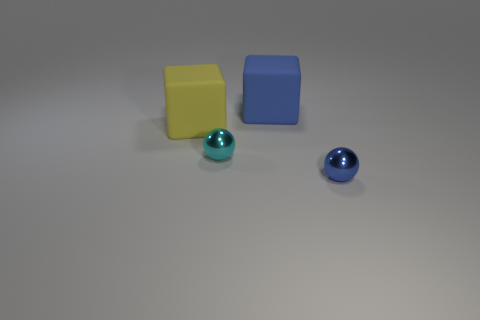Does the large yellow thing have the same material as the tiny cyan ball?
Provide a short and direct response. No. There is another rubber thing that is the same shape as the big blue object; what is its color?
Keep it short and to the point. Yellow. Do the block that is to the left of the cyan metal ball and the blue matte thing have the same size?
Provide a short and direct response. Yes. What number of blue balls are made of the same material as the yellow cube?
Give a very brief answer. 0. What is the material of the block left of the small metal ball that is behind the shiny object that is on the right side of the small cyan shiny ball?
Your answer should be very brief. Rubber. There is a big rubber cube on the right side of the tiny thing that is behind the blue metal ball; what color is it?
Give a very brief answer. Blue. The thing that is the same size as the blue shiny sphere is what color?
Keep it short and to the point. Cyan. How many large objects are cyan metal objects or balls?
Your answer should be compact. 0. Is the number of big rubber blocks that are behind the yellow rubber thing greater than the number of cyan shiny things in front of the small cyan metallic thing?
Offer a very short reply. Yes. Do the tiny thing that is to the right of the tiny cyan sphere and the large yellow cube have the same material?
Offer a very short reply. No. 